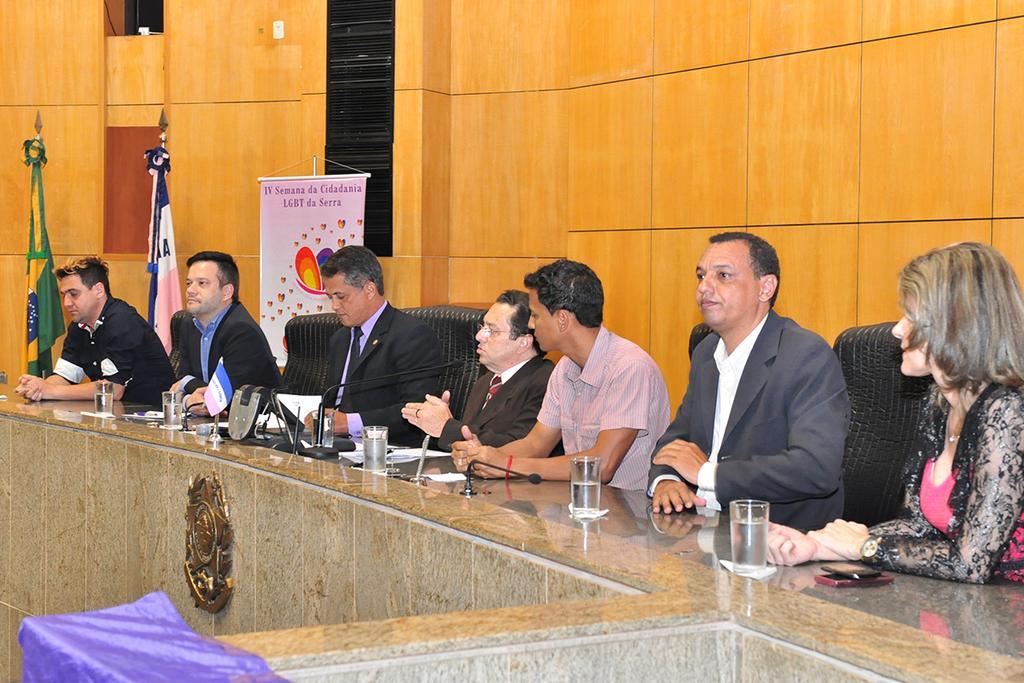In one or two sentences, can you explain what this image depicts? In this picture I can see people sitting on the chairs. I can see water glasses on the surface. I can see the microphone. I can see the banner. 